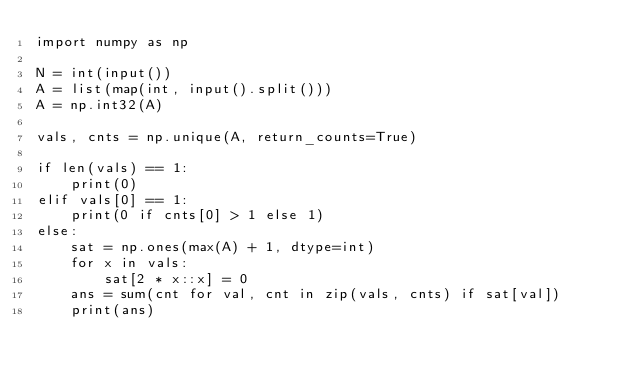Convert code to text. <code><loc_0><loc_0><loc_500><loc_500><_Python_>import numpy as np

N = int(input())
A = list(map(int, input().split()))
A = np.int32(A)

vals, cnts = np.unique(A, return_counts=True)

if len(vals) == 1:
    print(0)
elif vals[0] == 1:
    print(0 if cnts[0] > 1 else 1)
else:
    sat = np.ones(max(A) + 1, dtype=int)
    for x in vals:
        sat[2 * x::x] = 0
    ans = sum(cnt for val, cnt in zip(vals, cnts) if sat[val])
    print(ans)
</code> 